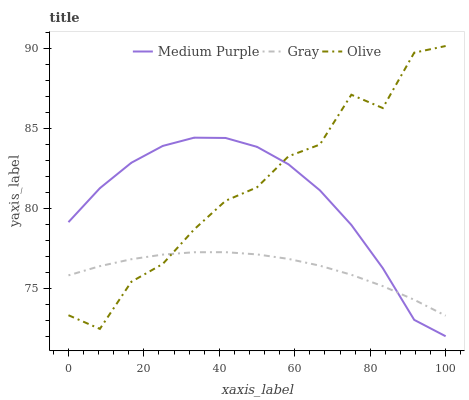Does Gray have the minimum area under the curve?
Answer yes or no. Yes. Does Olive have the maximum area under the curve?
Answer yes or no. Yes. Does Olive have the minimum area under the curve?
Answer yes or no. No. Does Gray have the maximum area under the curve?
Answer yes or no. No. Is Gray the smoothest?
Answer yes or no. Yes. Is Olive the roughest?
Answer yes or no. Yes. Is Olive the smoothest?
Answer yes or no. No. Is Gray the roughest?
Answer yes or no. No. Does Olive have the lowest value?
Answer yes or no. No. Does Olive have the highest value?
Answer yes or no. Yes. Does Gray have the highest value?
Answer yes or no. No. Does Medium Purple intersect Gray?
Answer yes or no. Yes. Is Medium Purple less than Gray?
Answer yes or no. No. Is Medium Purple greater than Gray?
Answer yes or no. No. 